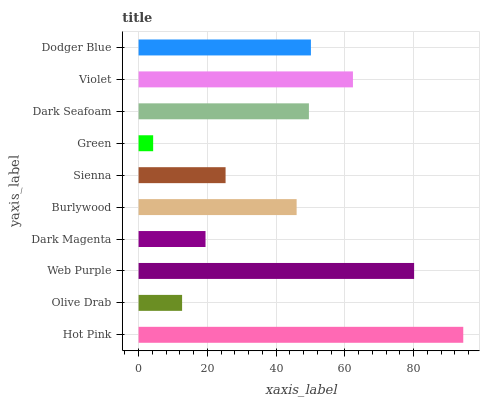Is Green the minimum?
Answer yes or no. Yes. Is Hot Pink the maximum?
Answer yes or no. Yes. Is Olive Drab the minimum?
Answer yes or no. No. Is Olive Drab the maximum?
Answer yes or no. No. Is Hot Pink greater than Olive Drab?
Answer yes or no. Yes. Is Olive Drab less than Hot Pink?
Answer yes or no. Yes. Is Olive Drab greater than Hot Pink?
Answer yes or no. No. Is Hot Pink less than Olive Drab?
Answer yes or no. No. Is Dark Seafoam the high median?
Answer yes or no. Yes. Is Burlywood the low median?
Answer yes or no. Yes. Is Olive Drab the high median?
Answer yes or no. No. Is Sienna the low median?
Answer yes or no. No. 